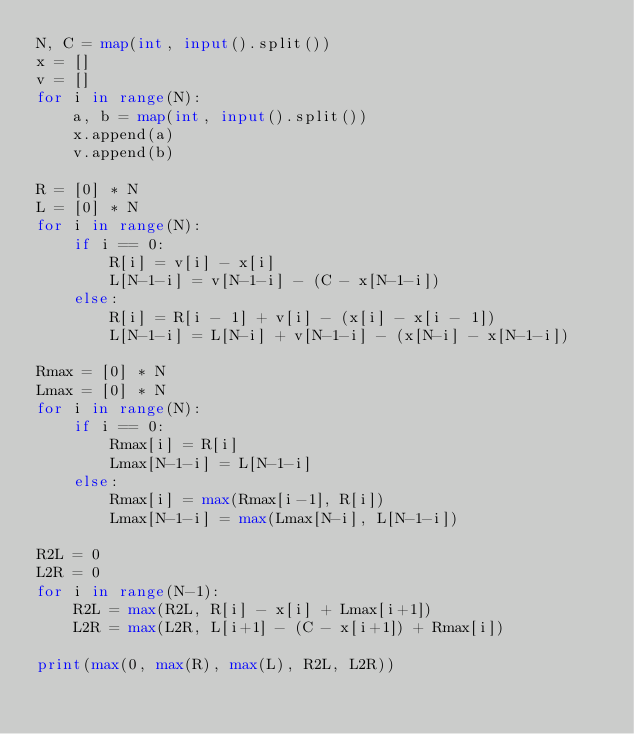<code> <loc_0><loc_0><loc_500><loc_500><_Python_>N, C = map(int, input().split())
x = []
v = []
for i in range(N):
    a, b = map(int, input().split())
    x.append(a)
    v.append(b)

R = [0] * N
L = [0] * N
for i in range(N):
    if i == 0:
        R[i] = v[i] - x[i]
        L[N-1-i] = v[N-1-i] - (C - x[N-1-i])
    else:
        R[i] = R[i - 1] + v[i] - (x[i] - x[i - 1])
        L[N-1-i] = L[N-i] + v[N-1-i] - (x[N-i] - x[N-1-i])

Rmax = [0] * N
Lmax = [0] * N
for i in range(N):
    if i == 0:
        Rmax[i] = R[i]
        Lmax[N-1-i] = L[N-1-i]
    else:
        Rmax[i] = max(Rmax[i-1], R[i])
        Lmax[N-1-i] = max(Lmax[N-i], L[N-1-i])

R2L = 0
L2R = 0
for i in range(N-1):
    R2L = max(R2L, R[i] - x[i] + Lmax[i+1])
    L2R = max(L2R, L[i+1] - (C - x[i+1]) + Rmax[i])

print(max(0, max(R), max(L), R2L, L2R))</code> 